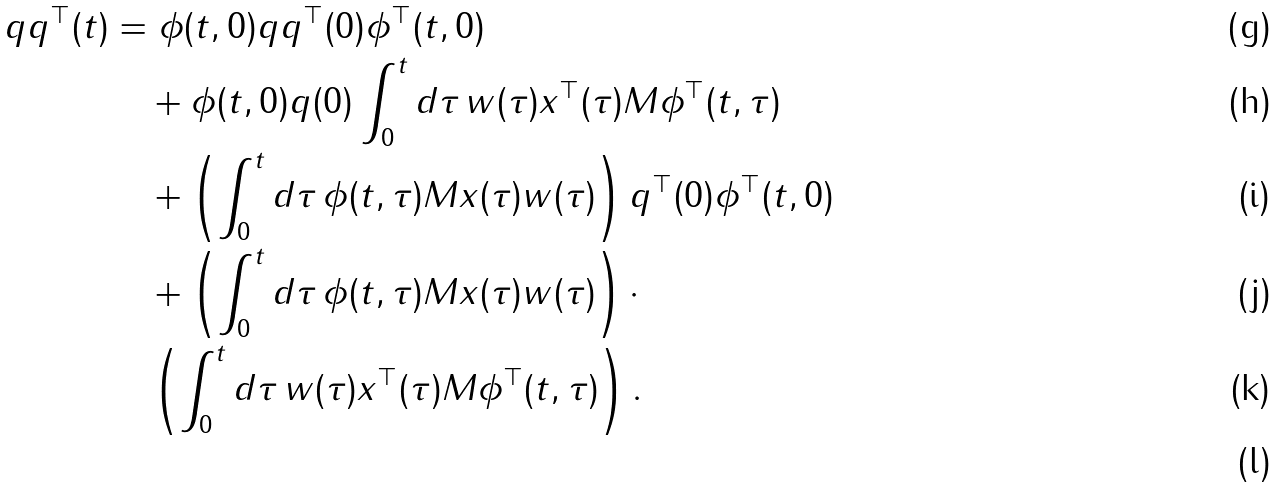Convert formula to latex. <formula><loc_0><loc_0><loc_500><loc_500>q q ^ { \top } ( t ) & = \phi ( t , 0 ) q q ^ { \top } ( 0 ) \phi ^ { \top } ( t , 0 ) \\ & \quad + \phi ( t , 0 ) q ( 0 ) \int _ { 0 } ^ { t } d \tau \, w ( \tau ) x ^ { \top } ( \tau ) M \phi ^ { \top } ( t , \tau ) \\ & \quad + \left ( \int _ { 0 } ^ { t } d \tau \, \phi ( t , \tau ) M x ( \tau ) w ( \tau ) \right ) q ^ { \top } ( 0 ) \phi ^ { \top } ( t , 0 ) \\ & \quad + \left ( \int _ { 0 } ^ { t } d \tau \, \phi ( t , \tau ) M x ( \tau ) w ( \tau ) \right ) \cdot \\ & \quad \left ( \int _ { 0 } ^ { t } d \tau \, w ( \tau ) x ^ { \top } ( \tau ) M \phi ^ { \top } ( t , \tau ) \right ) . \\</formula> 